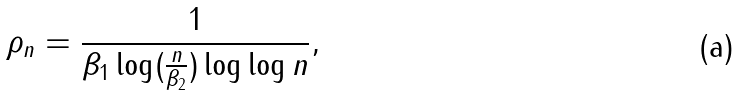Convert formula to latex. <formula><loc_0><loc_0><loc_500><loc_500>\rho _ { n } = \frac { 1 } { \beta _ { 1 } \log ( \frac { n } { \beta _ { 2 } } ) \log \log n } ,</formula> 